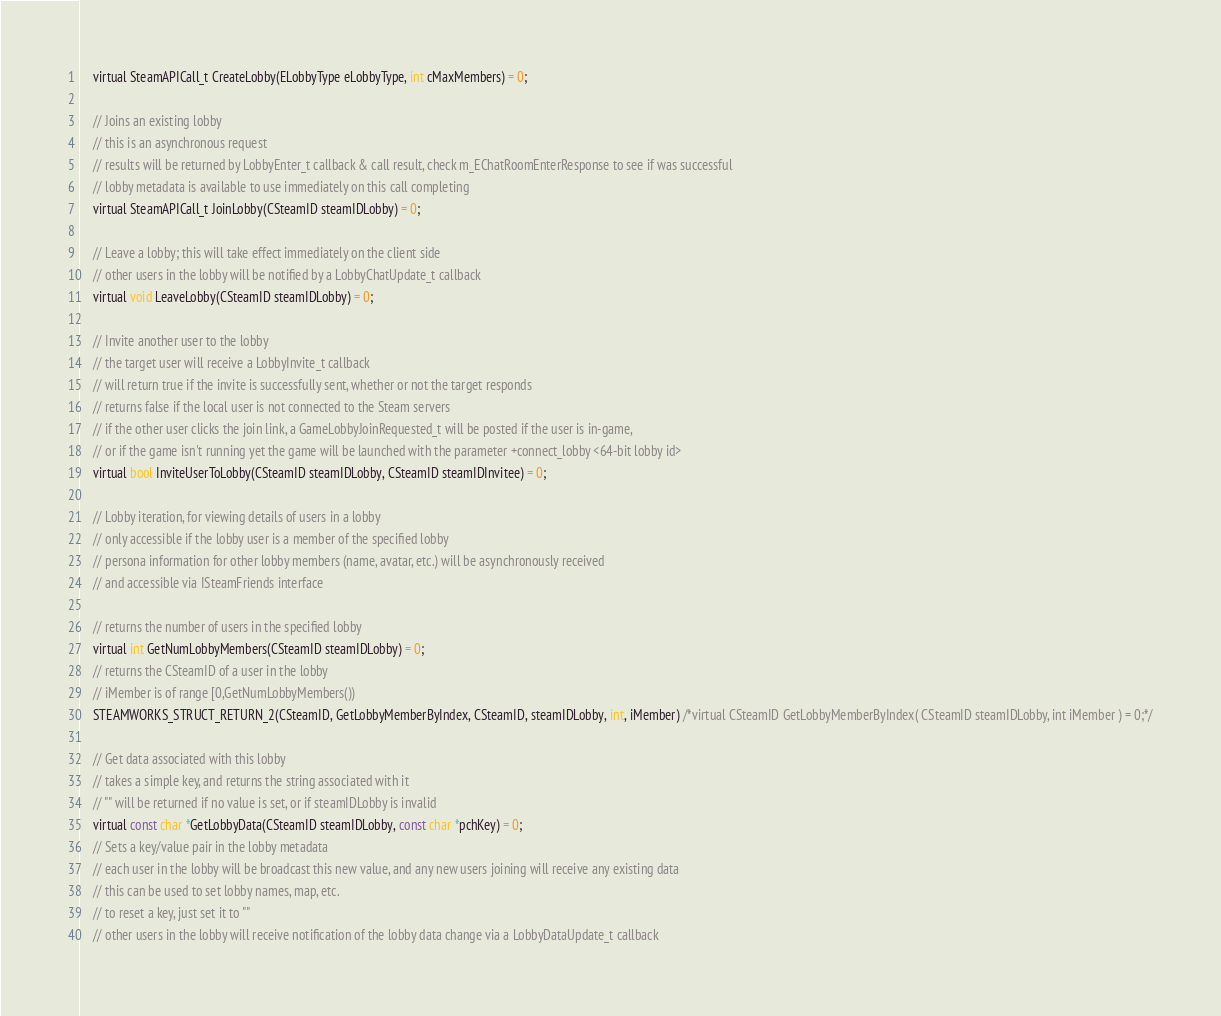<code> <loc_0><loc_0><loc_500><loc_500><_C_>	virtual SteamAPICall_t CreateLobby(ELobbyType eLobbyType, int cMaxMembers) = 0;

	// Joins an existing lobby
	// this is an asynchronous request
	// results will be returned by LobbyEnter_t callback & call result, check m_EChatRoomEnterResponse to see if was successful
	// lobby metadata is available to use immediately on this call completing
	virtual SteamAPICall_t JoinLobby(CSteamID steamIDLobby) = 0;

	// Leave a lobby; this will take effect immediately on the client side
	// other users in the lobby will be notified by a LobbyChatUpdate_t callback
	virtual void LeaveLobby(CSteamID steamIDLobby) = 0;

	// Invite another user to the lobby
	// the target user will receive a LobbyInvite_t callback
	// will return true if the invite is successfully sent, whether or not the target responds
	// returns false if the local user is not connected to the Steam servers
	// if the other user clicks the join link, a GameLobbyJoinRequested_t will be posted if the user is in-game,
	// or if the game isn't running yet the game will be launched with the parameter +connect_lobby <64-bit lobby id>
	virtual bool InviteUserToLobby(CSteamID steamIDLobby, CSteamID steamIDInvitee) = 0;

	// Lobby iteration, for viewing details of users in a lobby
	// only accessible if the lobby user is a member of the specified lobby
	// persona information for other lobby members (name, avatar, etc.) will be asynchronously received
	// and accessible via ISteamFriends interface

	// returns the number of users in the specified lobby
	virtual int GetNumLobbyMembers(CSteamID steamIDLobby) = 0;
	// returns the CSteamID of a user in the lobby
	// iMember is of range [0,GetNumLobbyMembers())
	STEAMWORKS_STRUCT_RETURN_2(CSteamID, GetLobbyMemberByIndex, CSteamID, steamIDLobby, int, iMember) /*virtual CSteamID GetLobbyMemberByIndex( CSteamID steamIDLobby, int iMember ) = 0;*/

	// Get data associated with this lobby
	// takes a simple key, and returns the string associated with it
	// "" will be returned if no value is set, or if steamIDLobby is invalid
	virtual const char *GetLobbyData(CSteamID steamIDLobby, const char *pchKey) = 0;
	// Sets a key/value pair in the lobby metadata
	// each user in the lobby will be broadcast this new value, and any new users joining will receive any existing data
	// this can be used to set lobby names, map, etc.
	// to reset a key, just set it to ""
	// other users in the lobby will receive notification of the lobby data change via a LobbyDataUpdate_t callback</code> 